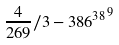Convert formula to latex. <formula><loc_0><loc_0><loc_500><loc_500>\frac { 4 } { 2 6 9 } / 3 - { 3 8 6 ^ { 3 8 } } ^ { 9 }</formula> 